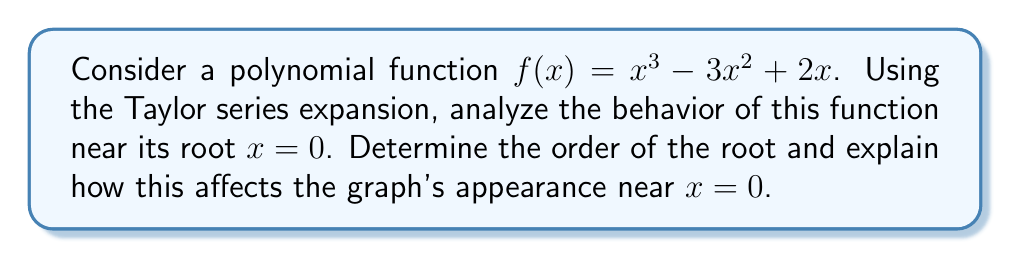Give your solution to this math problem. Let's approach this step-by-step:

1) First, we need to find the Taylor series expansion of $f(x)$ around $x = 0$:

   $$f(x) = f(0) + f'(0)x + \frac{f''(0)}{2!}x^2 + \frac{f'''(0)}{3!}x^3 + ...$$

2) Calculate the derivatives and their values at $x = 0$:
   
   $f(x) = x^3 - 3x^2 + 2x$
   $f'(x) = 3x^2 - 6x + 2$
   $f''(x) = 6x - 6$
   $f'''(x) = 6$

   $f(0) = 0$
   $f'(0) = 2$
   $f''(0) = -6$
   $f'''(0) = 6$

3) Substitute these values into the Taylor series:

   $$f(x) = 0 + 2x + \frac{-6}{2!}x^2 + \frac{6}{3!}x^3 + ...$$

   $$f(x) = 2x - 3x^2 + x^3 + ...$$

4) The first non-zero term in this expansion is $2x$, which is of order 1.

5) The order of the root is determined by the lowest power of $x$ in the Taylor series with a non-zero coefficient. In this case, it's 1, so $x = 0$ is a simple root.

6) For a simple root, the function crosses the x-axis at a non-zero angle. The graph will pass through the origin (0,0) and change from negative to positive (or vice versa) as it crosses the x-axis.

7) The behavior near $x = 0$ is primarily determined by the linear term $2x$. The quadratic and cubic terms become less significant as $x$ approaches 0.

8) The positive coefficient of the linear term (2) indicates that the function is increasing as it passes through the origin, moving from negative y-values to positive y-values as x increases.
Answer: Simple root; linear behavior near $x = 0$ 